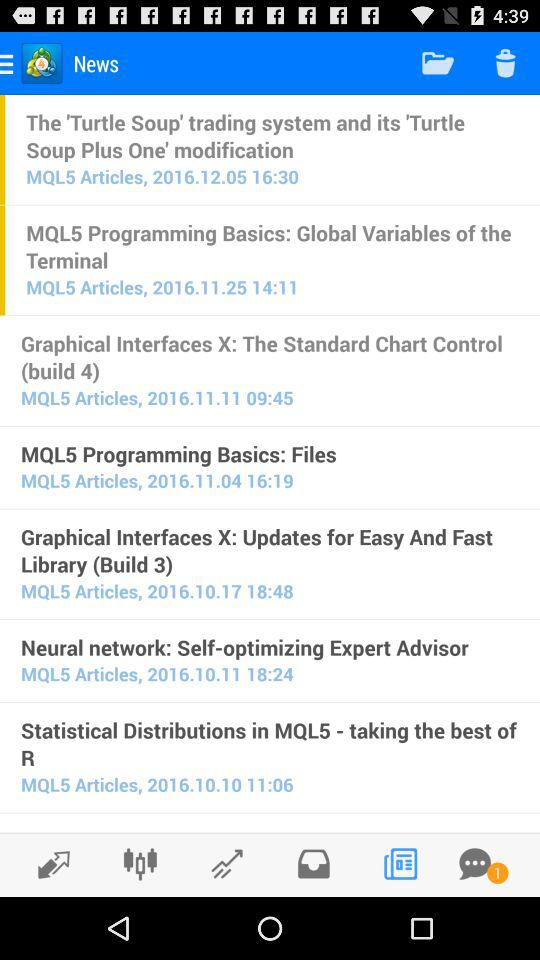What is the name of the application? The name of the application is "MetaTrader 4 Forex Trading". 